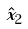<formula> <loc_0><loc_0><loc_500><loc_500>\hat { x } _ { 2 }</formula> 